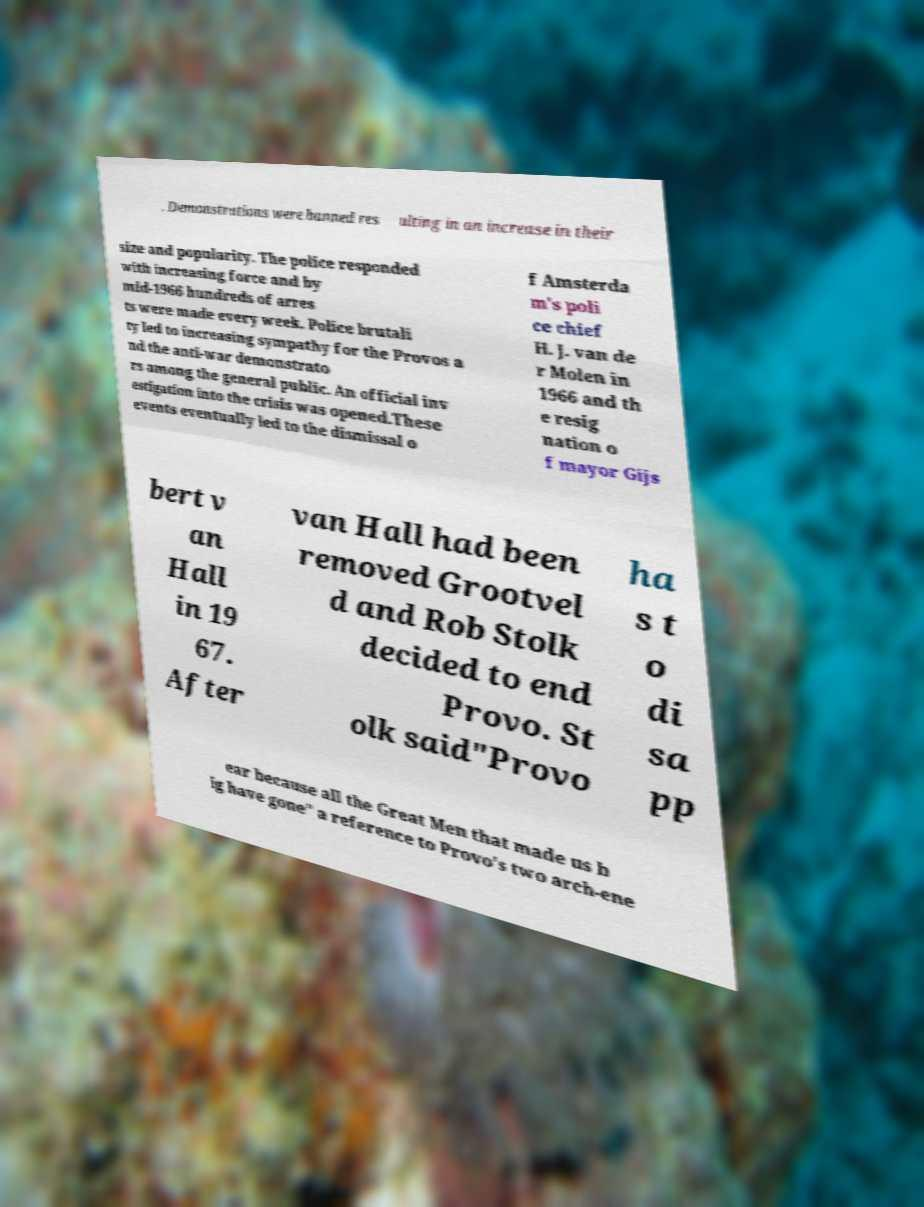Could you extract and type out the text from this image? . Demonstrations were banned res ulting in an increase in their size and popularity. The police responded with increasing force and by mid-1966 hundreds of arres ts were made every week. Police brutali ty led to increasing sympathy for the Provos a nd the anti-war demonstrato rs among the general public. An official inv estigation into the crisis was opened.These events eventually led to the dismissal o f Amsterda m's poli ce chief H. J. van de r Molen in 1966 and th e resig nation o f mayor Gijs bert v an Hall in 19 67. After van Hall had been removed Grootvel d and Rob Stolk decided to end Provo. St olk said"Provo ha s t o di sa pp ear because all the Great Men that made us b ig have gone" a reference to Provo's two arch-ene 